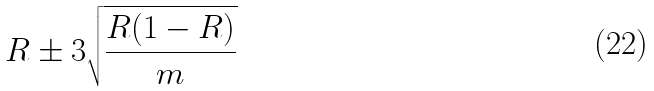Convert formula to latex. <formula><loc_0><loc_0><loc_500><loc_500>R \pm 3 \sqrt { \frac { R ( 1 - R ) } { m } }</formula> 